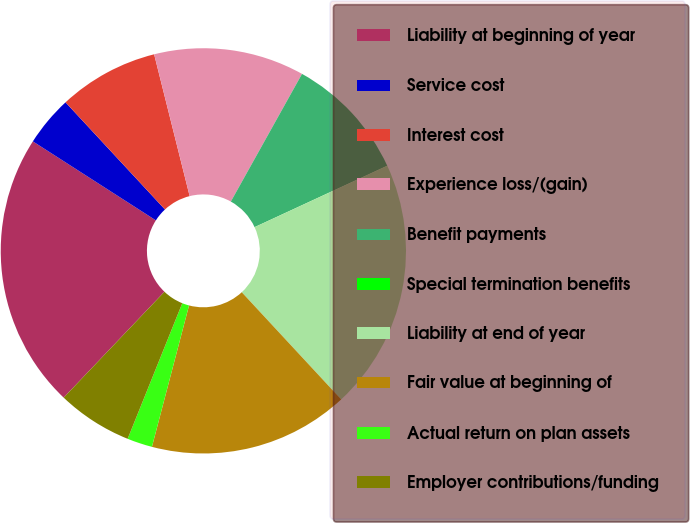Convert chart to OTSL. <chart><loc_0><loc_0><loc_500><loc_500><pie_chart><fcel>Liability at beginning of year<fcel>Service cost<fcel>Interest cost<fcel>Experience loss/(gain)<fcel>Benefit payments<fcel>Special termination benefits<fcel>Liability at end of year<fcel>Fair value at beginning of<fcel>Actual return on plan assets<fcel>Employer contributions/funding<nl><fcel>21.98%<fcel>4.01%<fcel>8.0%<fcel>12.0%<fcel>10.0%<fcel>0.01%<fcel>19.99%<fcel>15.99%<fcel>2.01%<fcel>6.01%<nl></chart> 